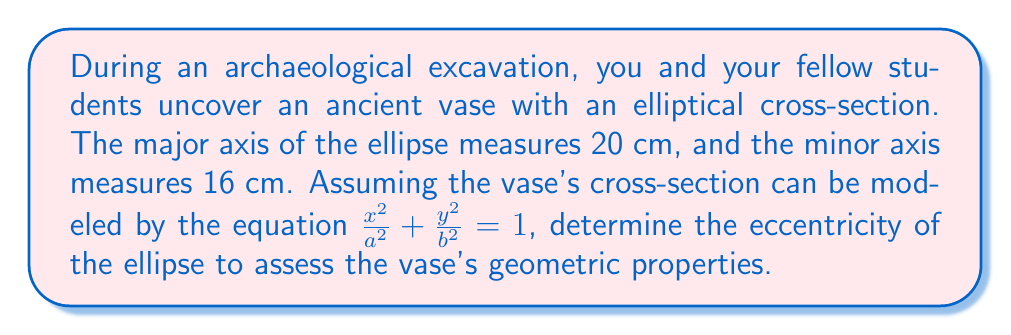Provide a solution to this math problem. Let's approach this step-by-step:

1) The general equation of an ellipse is $\frac{x^2}{a^2} + \frac{y^2}{b^2} = 1$, where $a$ is the length of the semi-major axis and $b$ is the length of the semi-minor axis.

2) We're given that the major axis is 20 cm and the minor axis is 16 cm. Therefore:
   $a = 10$ cm (half of 20 cm)
   $b = 8$ cm (half of 16 cm)

3) The eccentricity of an ellipse is defined as:

   $$e = \sqrt{1 - \frac{b^2}{a^2}}$$

4) Substituting our values:

   $$e = \sqrt{1 - \frac{8^2}{10^2}}$$

5) Simplify inside the square root:

   $$e = \sqrt{1 - \frac{64}{100}} = \sqrt{1 - 0.64} = \sqrt{0.36}$$

6) Simplify the square root:

   $$e = 0.6$$

Therefore, the eccentricity of the elliptical cross-section is 0.6.
Answer: 0.6 